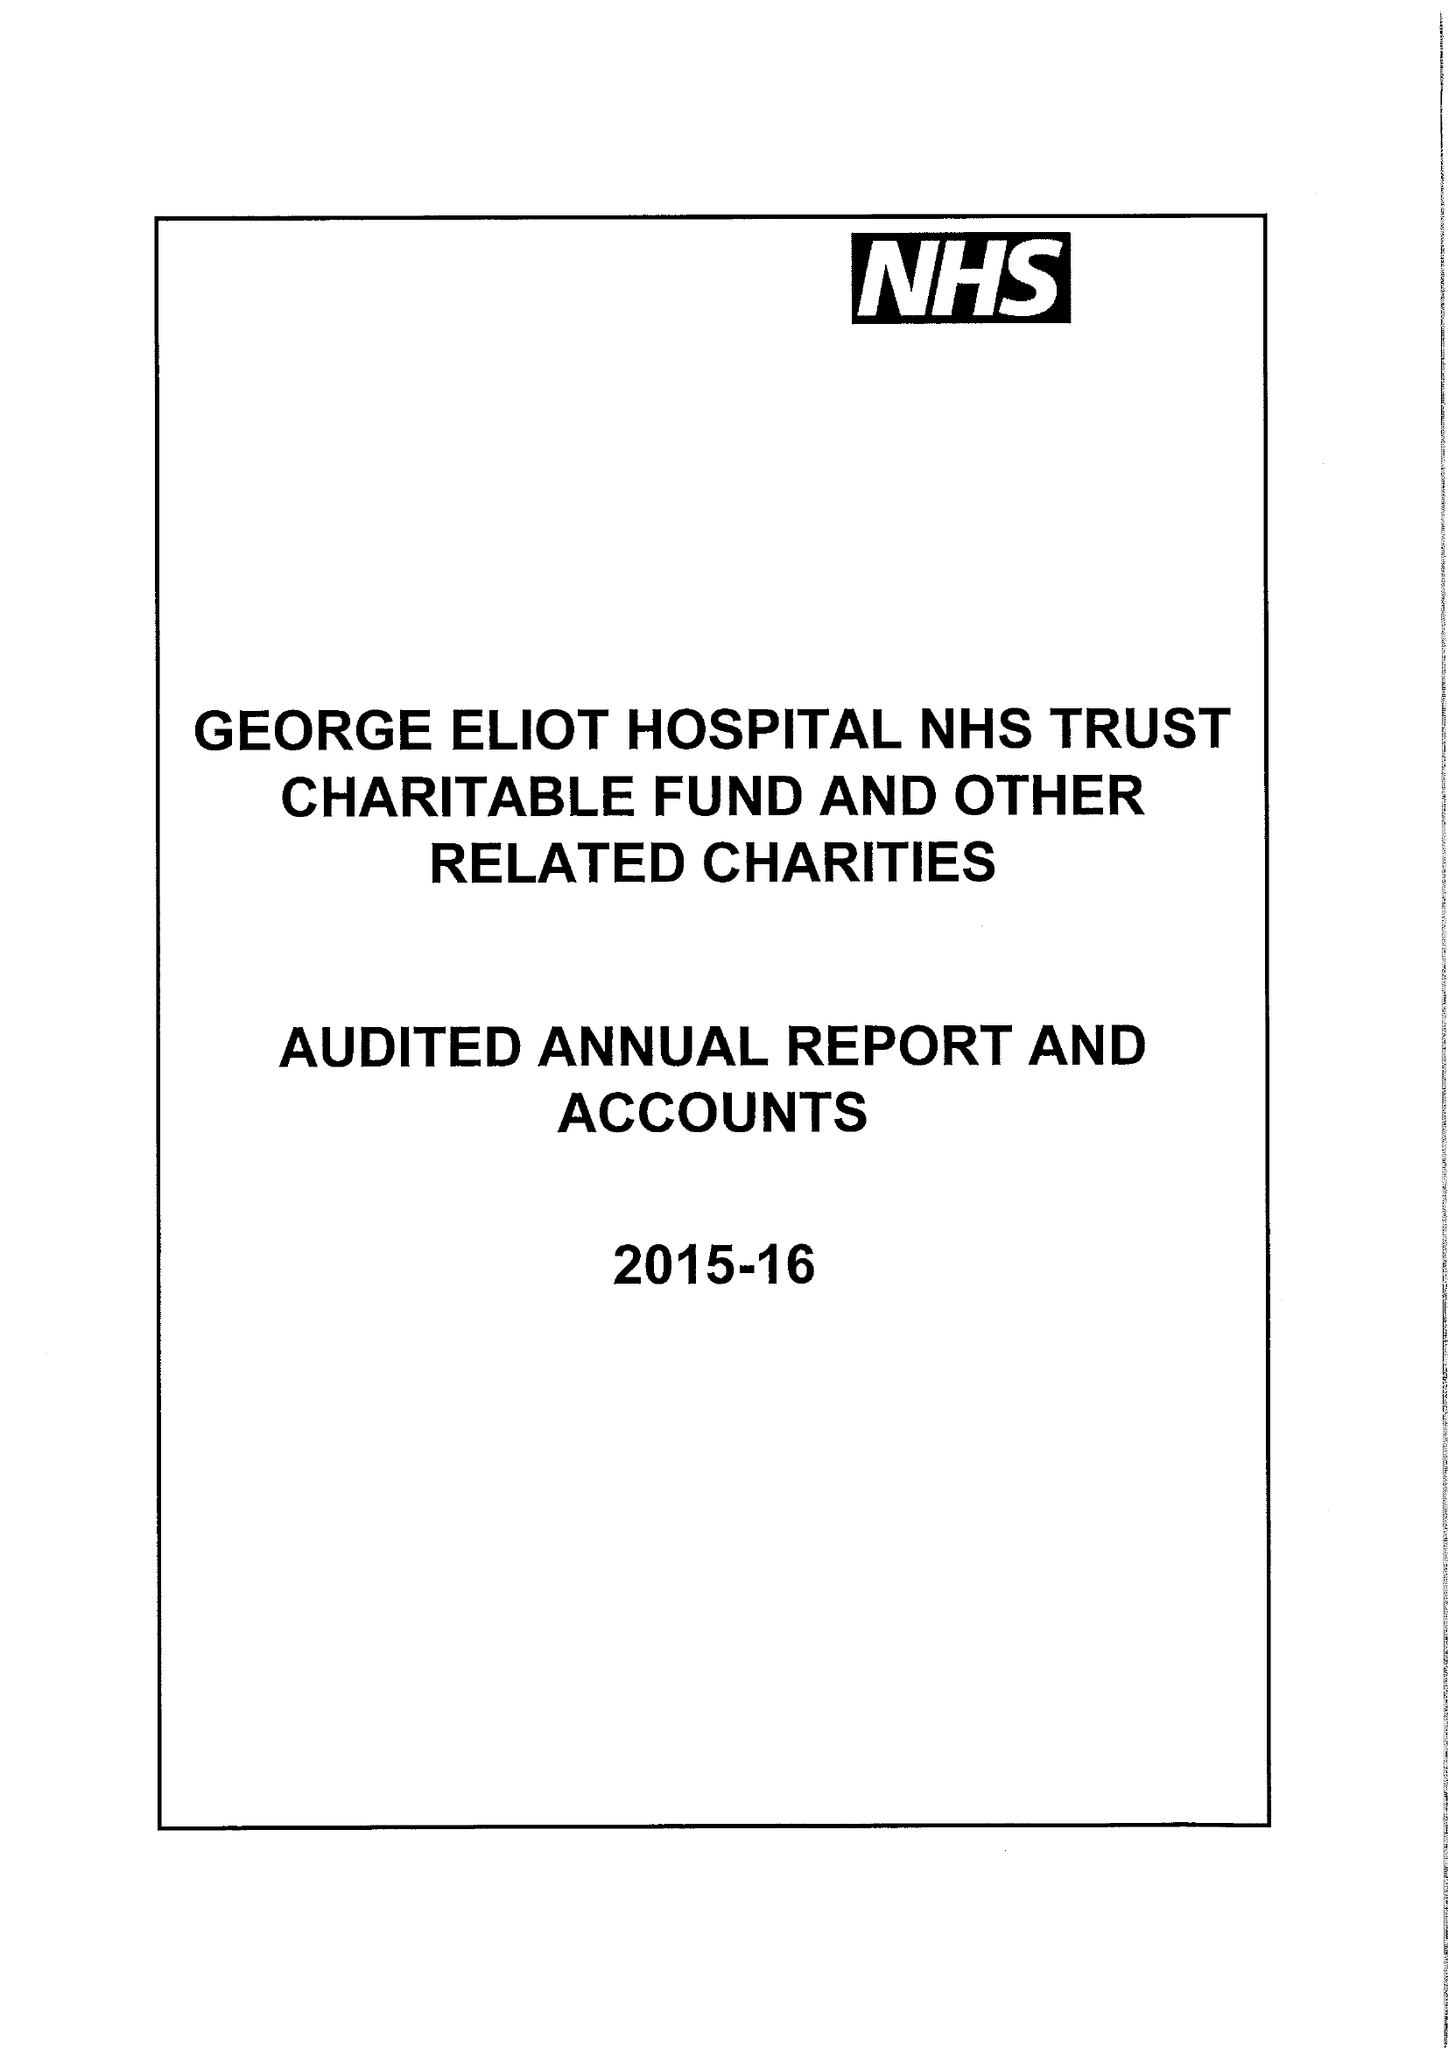What is the value for the address__street_line?
Answer the question using a single word or phrase. COLLEGE STREET 